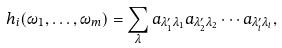Convert formula to latex. <formula><loc_0><loc_0><loc_500><loc_500>h _ { i } ( \omega _ { 1 } , \dots , \omega _ { m } ) = \sum _ { \lambda } a _ { \lambda ^ { \prime } _ { 1 } \lambda _ { 1 } } a _ { \lambda ^ { \prime } _ { 2 } \lambda _ { 2 } } \cdots a _ { \lambda ^ { \prime } _ { i } \lambda _ { i } } ,</formula> 